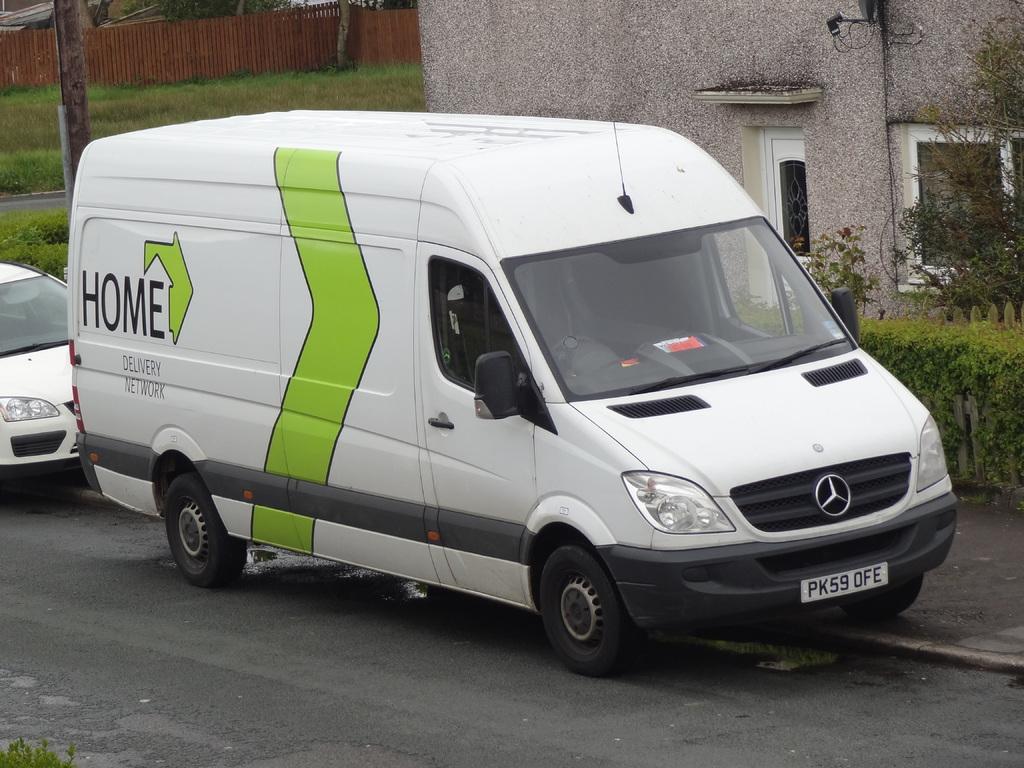What is the licence plate of the truck?
Your response must be concise. Pk59 ofe. What is the name on the side of the van?
Keep it short and to the point. Home. 